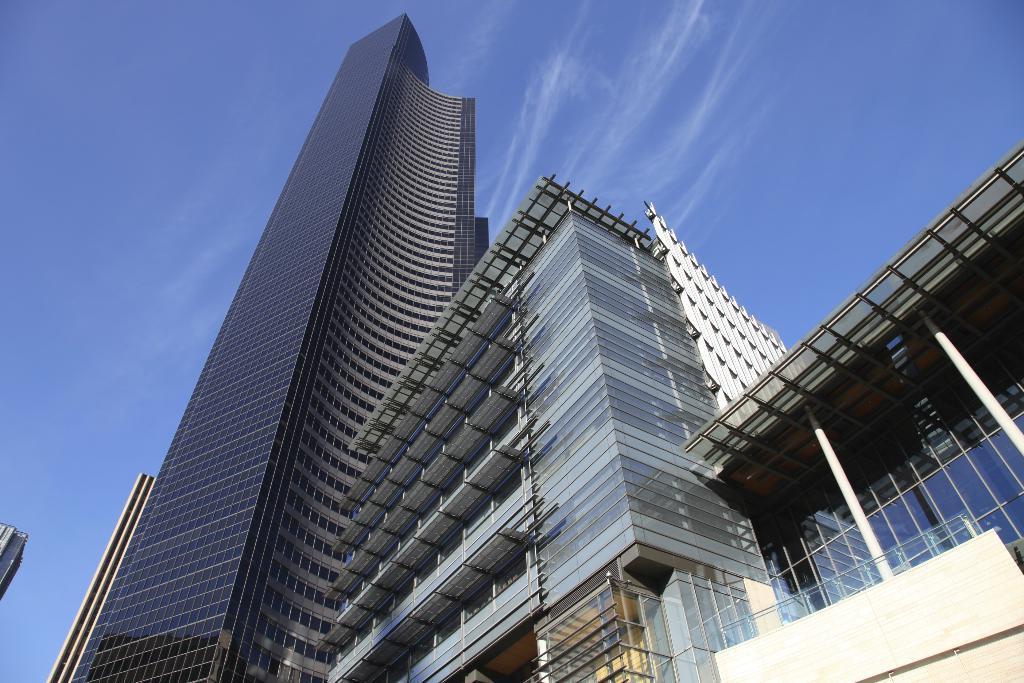Please provide a concise description of this image. In this image we can see some buildings with windows. On the backside we can see the sky which looks cloudy. 